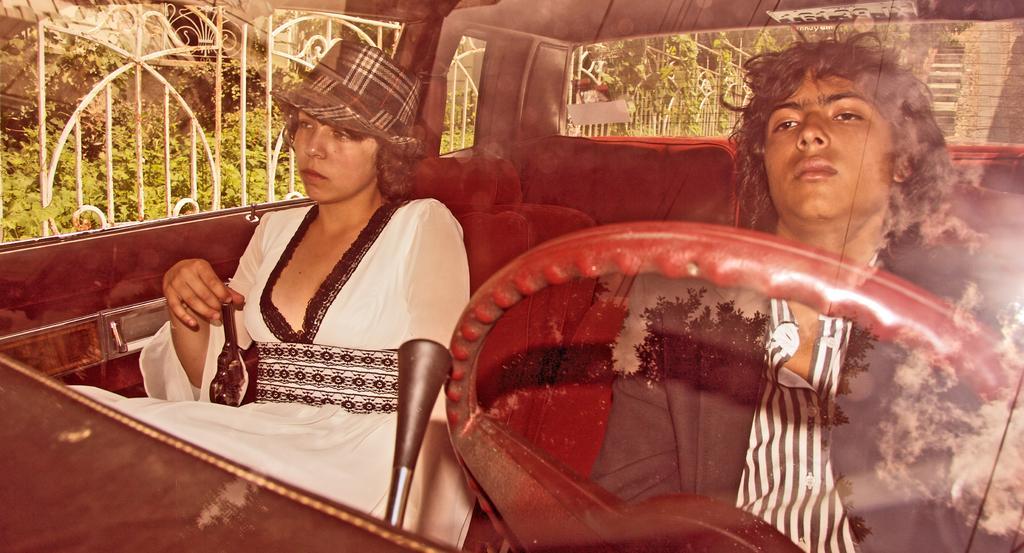Describe this image in one or two sentences. In this image I can see 2 people sitting in a car. There is a steering in the front. Through the car windows I can see fence and plants. 